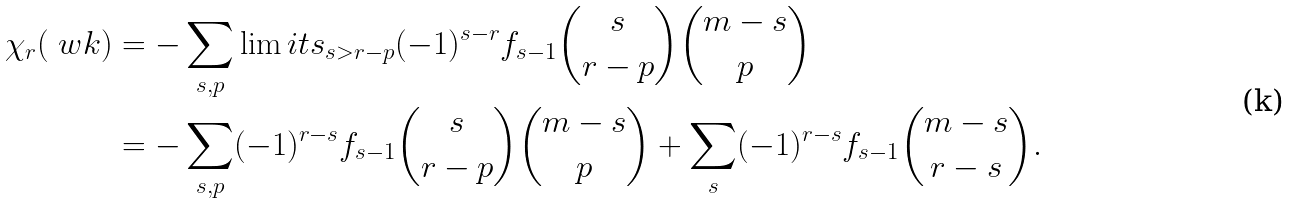Convert formula to latex. <formula><loc_0><loc_0><loc_500><loc_500>\chi _ { r } ( \ w k ) & = - \sum _ { s , p } \lim i t s _ { s > r - p } ( - 1 ) ^ { s - r } f _ { s - 1 } { \binom { s } { r - p } \binom { m - s } p } \\ & = - \sum _ { s , p } ( - 1 ) ^ { r - s } f _ { s - 1 } { \binom { s } { r - p } \binom { m - s } p } + \sum _ { s } ( - 1 ) ^ { r - s } f _ { s - 1 } { \binom { m - s } { r - s } } .</formula> 